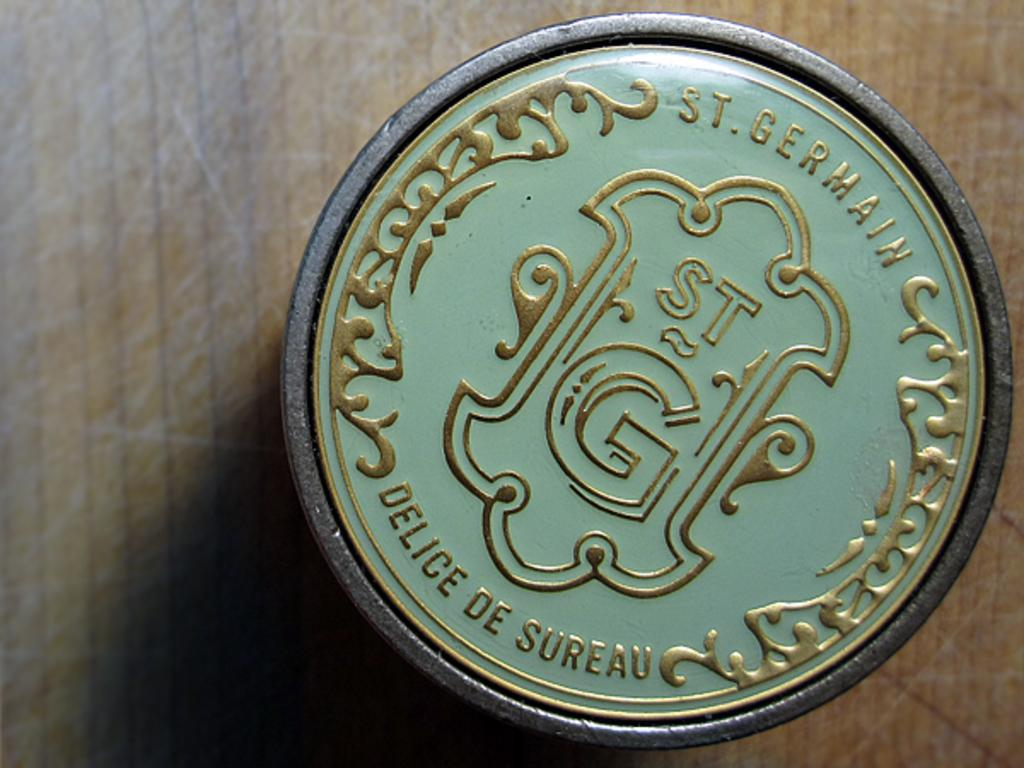<image>
Create a compact narrative representing the image presented. The ornament shown in green and gold says St. Germain at the top. 